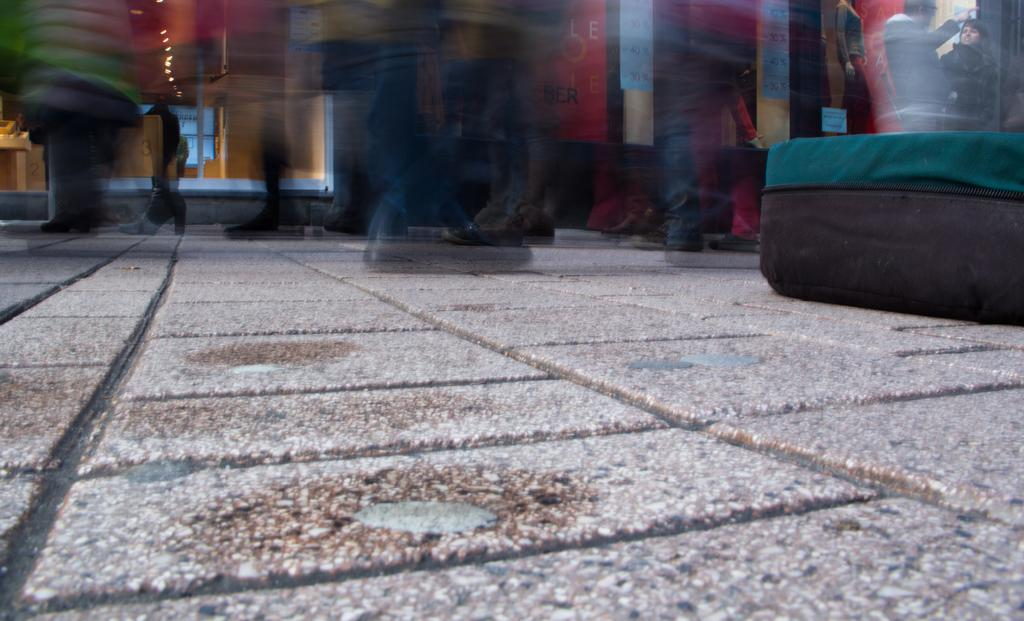What is the main subject of the image? The main subject of the image is the floor of a room. Can you describe any other elements in the room? Yes, there are people in the room. How is the background of the image depicted? The background of the image is blurred. Can you tell me how many baseballs are floating in the liquid in the image? There are no baseballs or liquid present in the image; it is a picture of the floor of a room. 